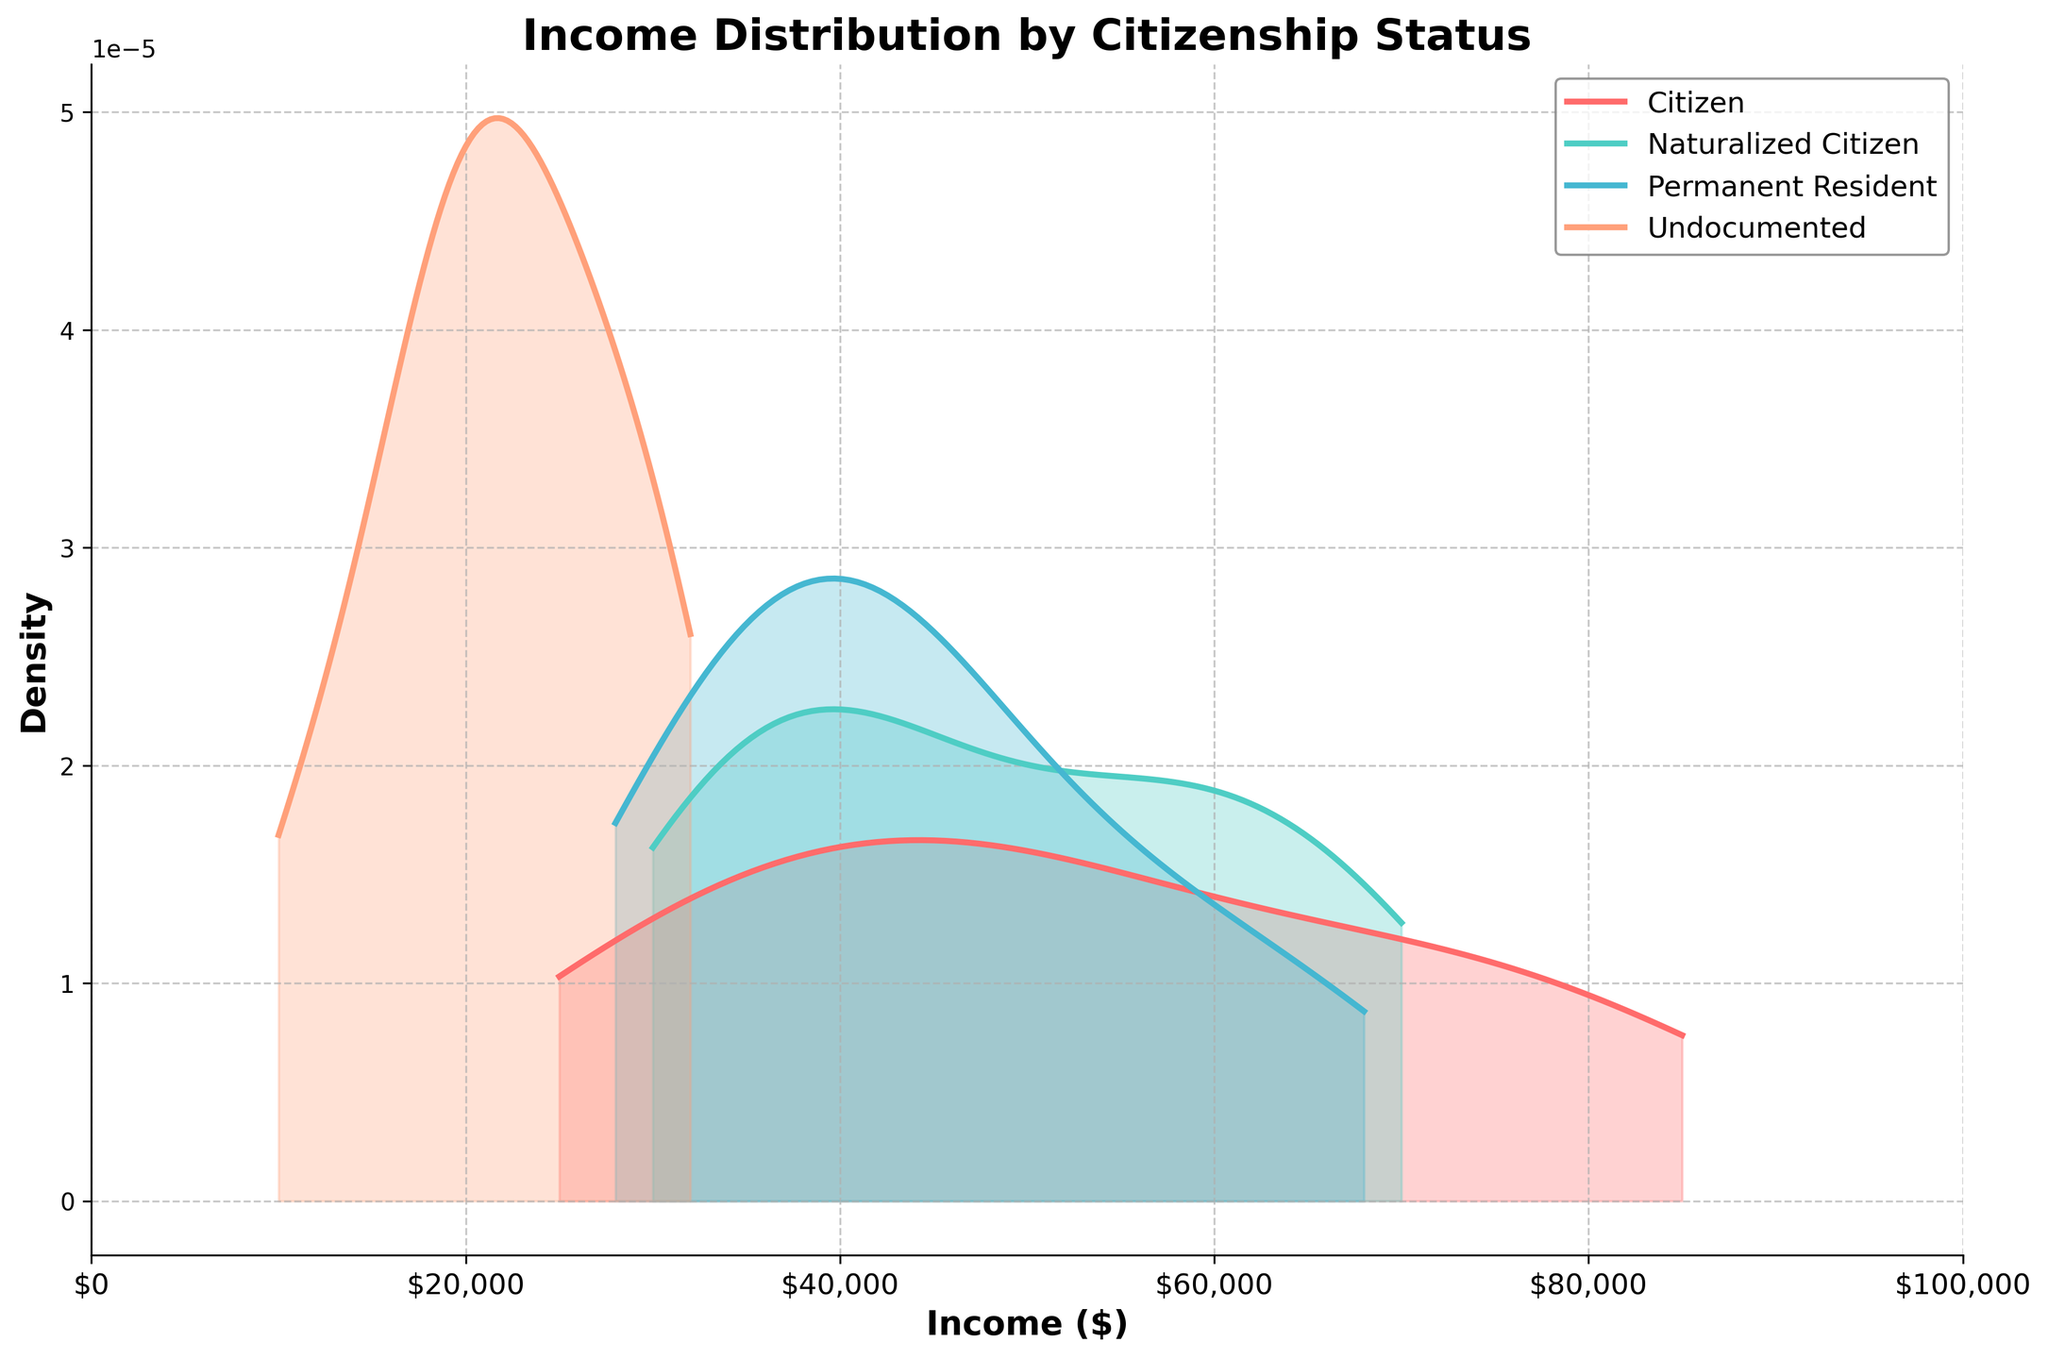What is the title of the plot? The title is usually located at the top of the plot. From the given details, it is clear that the title is "Income Distribution by Citizenship Status".
Answer: Income Distribution by Citizenship Status Which citizenship status has the lowest income distribution range? Refer to the density plots. The status with the range that starts from the lowest amount is "Undocumented".
Answer: Undocumented What is the most common income range for Permanent Residents? Look at the peak of the density curve for Permanent Residents (colored differently). The peak indicates the most common income range, which appears to be around $40,000 to $48,000.
Answer: $40,000 to $48,000 Do naturalized citizens generally have a higher income than permanent residents? Compare the peaks and distribution of the density curves for Naturalized Citizens and Permanent Residents. Naturalized Citizens have a higher peak in the $55,000 to $65,000 range, which is generally higher than the peak for Permanent Residents.
Answer: Yes Which citizenship status group shows the highest density of low-income earners? Observe which density plot has the highest peak at the lower end of the income spectrum. The "Undocumented" group shows the highest density in the lower income range.
Answer: Undocumented What are the income ranges that have no representation in the dataset for each citizenship status? Examine the density plots for gaps or areas where the density is zero. For Citizens, it's from $0 to $25,000. For Naturalized Citizens, it's $0 to $25,000. For Permanent Residents, it's $0 to $28,000. For Undocumented, it's above $32,000.
Answer: Citizens: $0 to $25,000, Naturalized Citizens: $0 to $25,000, Permanent Residents: $0 to $28,000, Undocumented: above $32,000 Which group has the widest income distribution range? Look at the spread of each density plot from the minimum to the maximum income values. The Citizens group appears to have the widest range, extending from $25,000 to $85,000.
Answer: Citizens What does the shaded area under each density curve represent? The shaded area under the density curve represents the probability density of the income distribution for each citizenship status. A greater shaded area indicates higher density or higher probability of incomes falling within that range.
Answer: Probability density of income distribution 